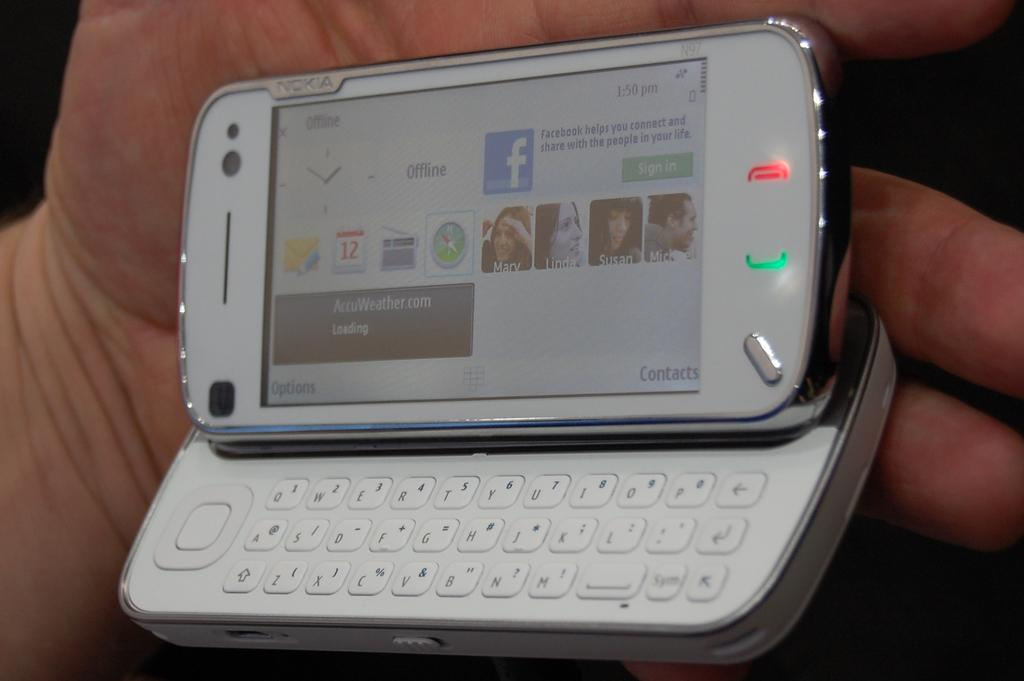<image>
Present a compact description of the photo's key features. a slider phone showing that it is OFFLINE at 1:50 PM 